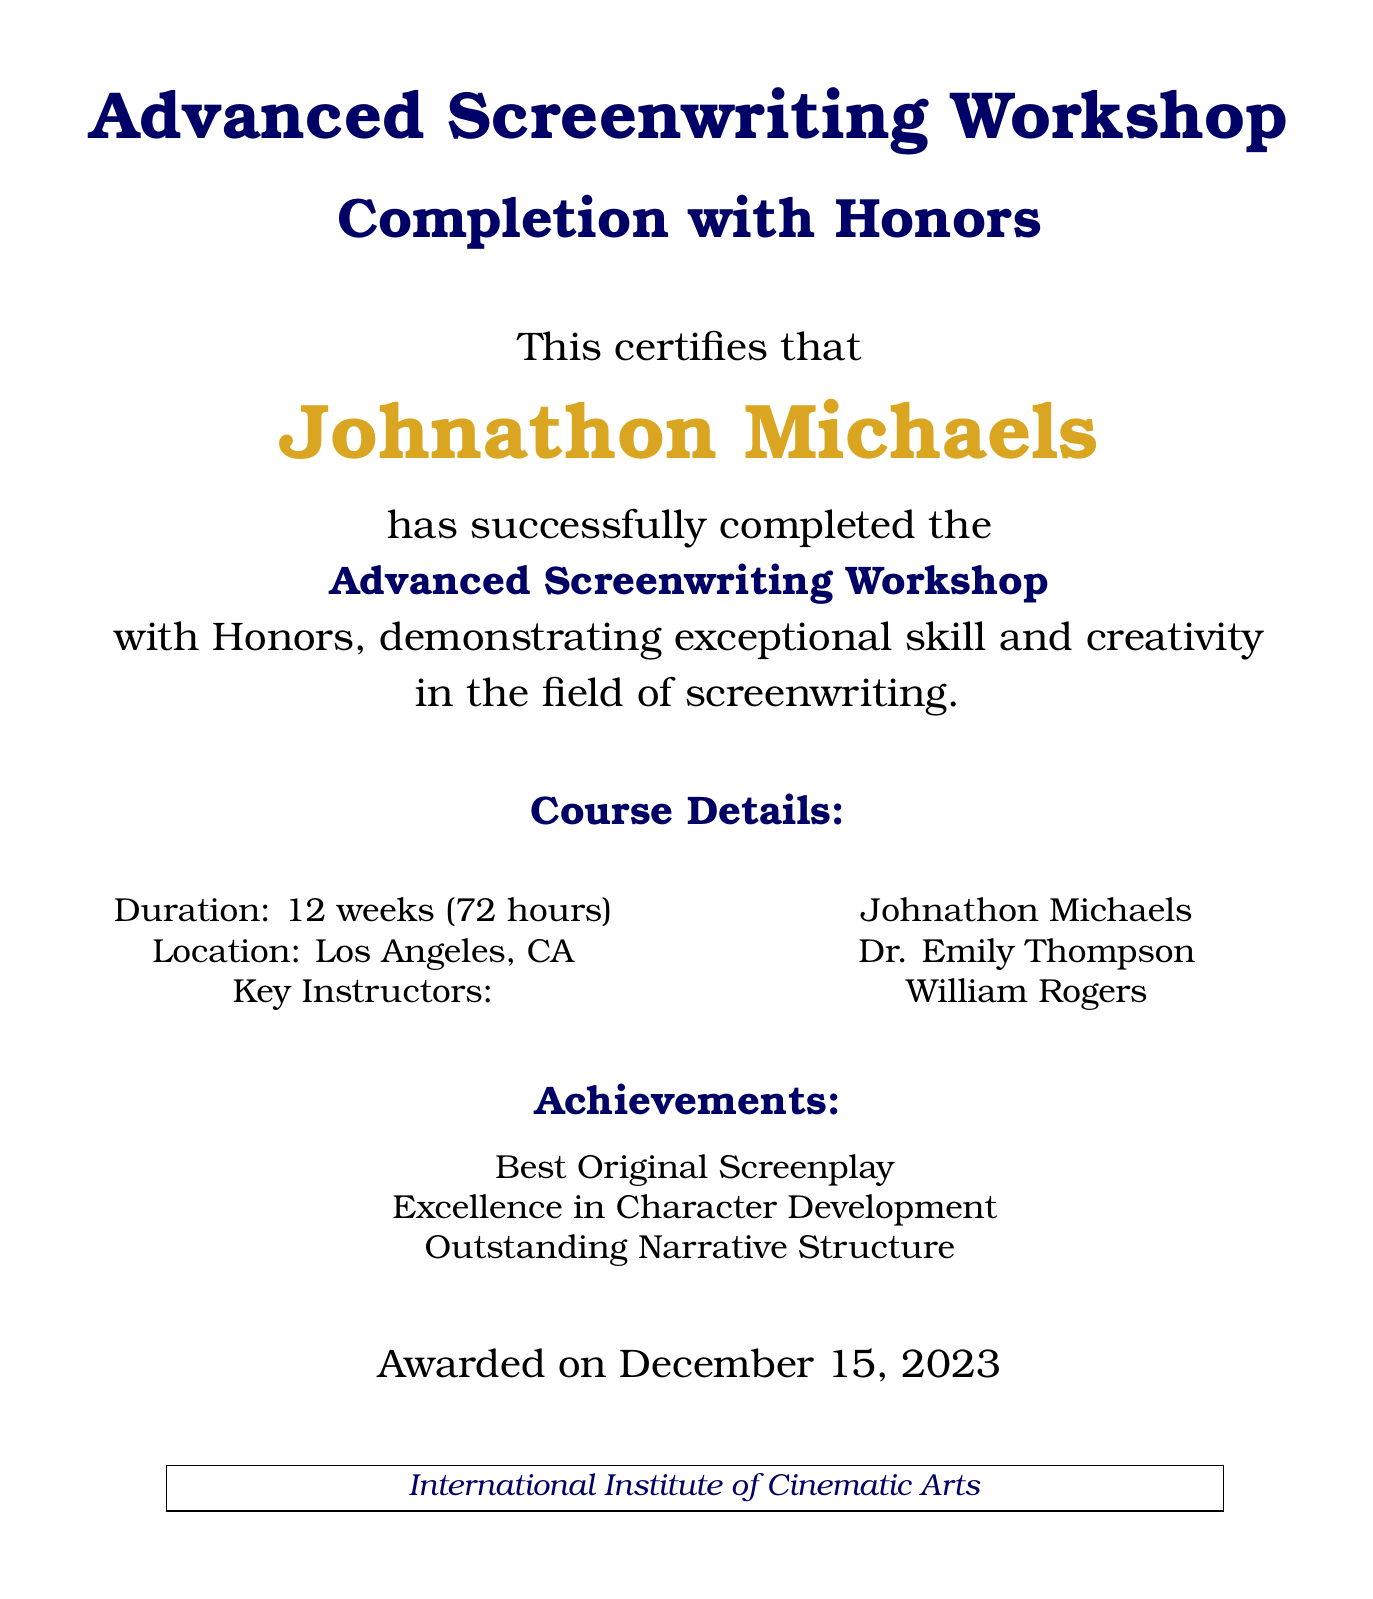What is the name of the award recipient? The document states the name of the award recipient is prominently displayed in gold accent, making it easy to identify.
Answer: Johnathon Michaels What is the date of the award presentation? The document explicitly mentions the date on which the award was given.
Answer: December 15, 2023 How long is the course duration? The document provides specific information about the total time spent in the course.
Answer: 12 weeks (72 hours) Where was the workshop location? The document states the city where the workshop was conducted, which is relevant for context.
Answer: Los Angeles, CA Who are the key instructors listed? The document contains a list of instructors who were part of the course, which highlights the expertise behind it.
Answer: Johnathon Michaels, Dr. Emily Thompson, William Rogers What kind of recognition did the recipient receive in terms of achievements? The document lists various commendations the recipient received during the course.
Answer: Best Original Screenplay, Excellence in Character Development, Outstanding Narrative Structure What type of document is this? This document serves a specific purpose in acknowledging achievements in an educational setting.
Answer: Diploma What color is used for the course title? The document uses a specific color to emphasize the course title, which adds to its visual appeal.
Answer: Dark blue 